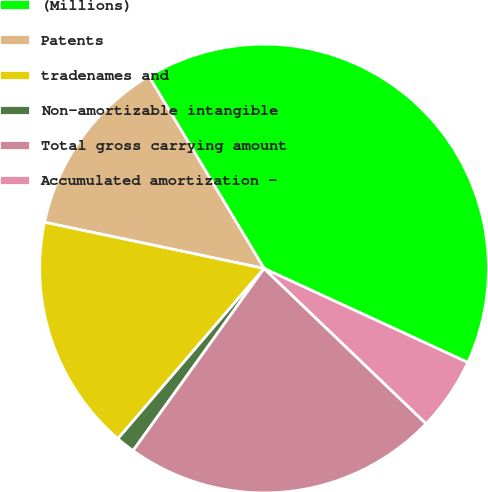Convert chart to OTSL. <chart><loc_0><loc_0><loc_500><loc_500><pie_chart><fcel>(Millions)<fcel>Patents<fcel>tradenames and<fcel>Non-amortizable intangible<fcel>Total gross carrying amount<fcel>Accumulated amortization -<nl><fcel>40.47%<fcel>13.1%<fcel>17.01%<fcel>1.37%<fcel>22.76%<fcel>5.28%<nl></chart> 